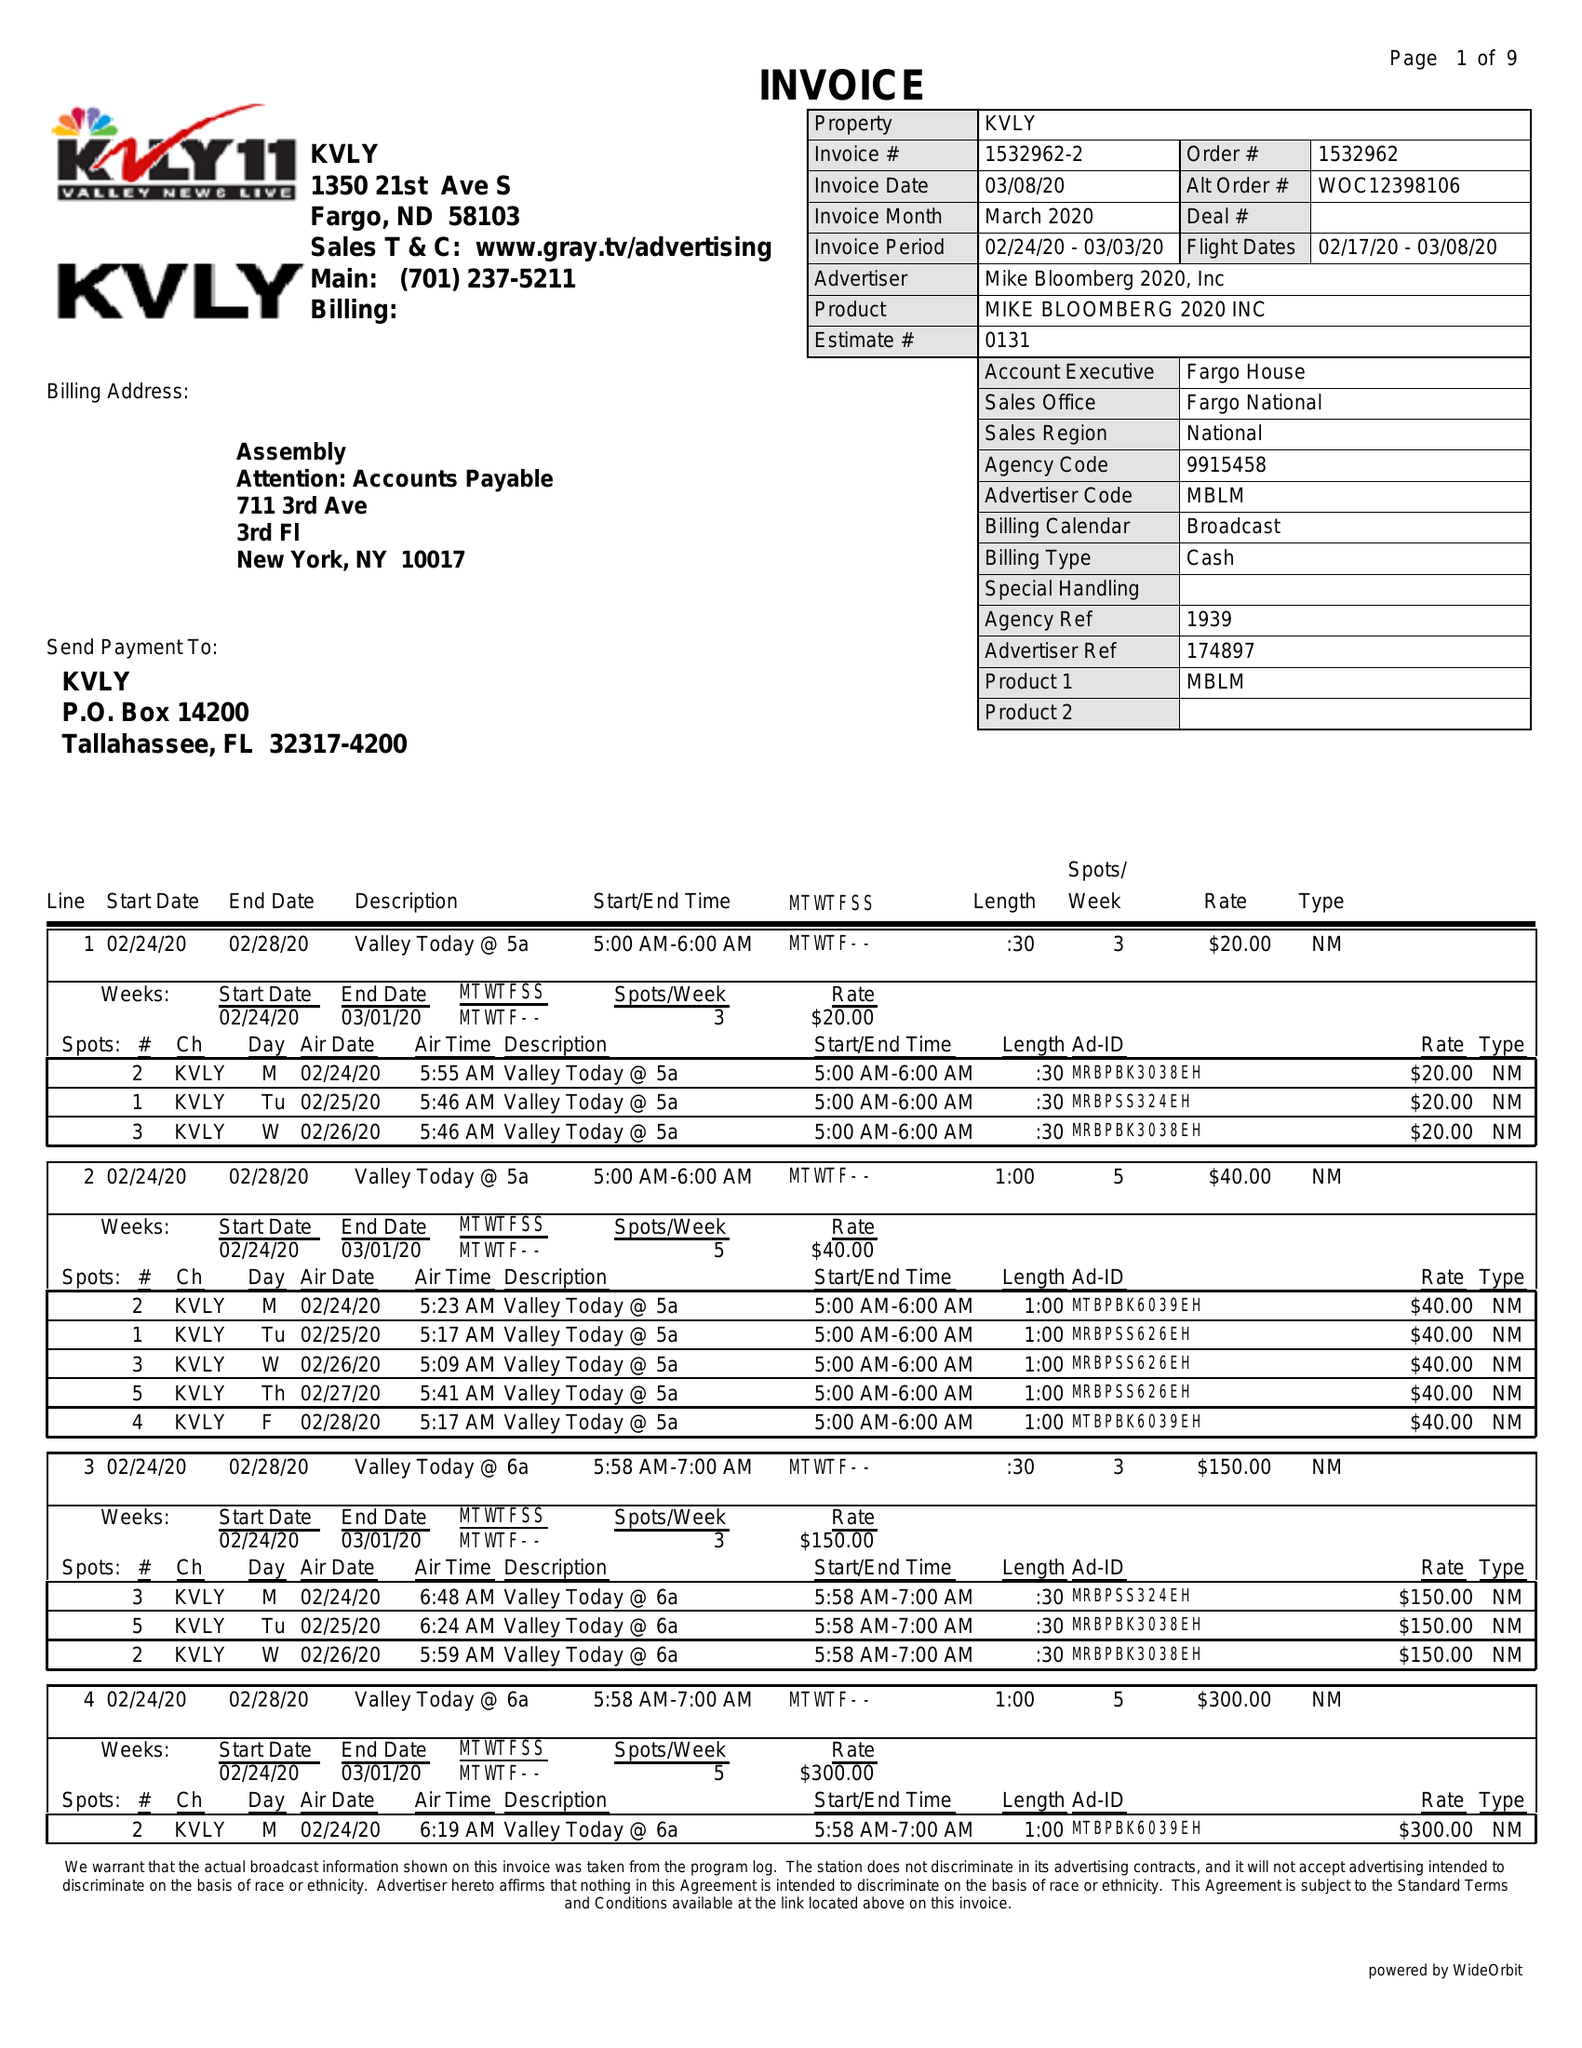What is the value for the advertiser?
Answer the question using a single word or phrase. MIKE BLOOMBERG 2020, INC 